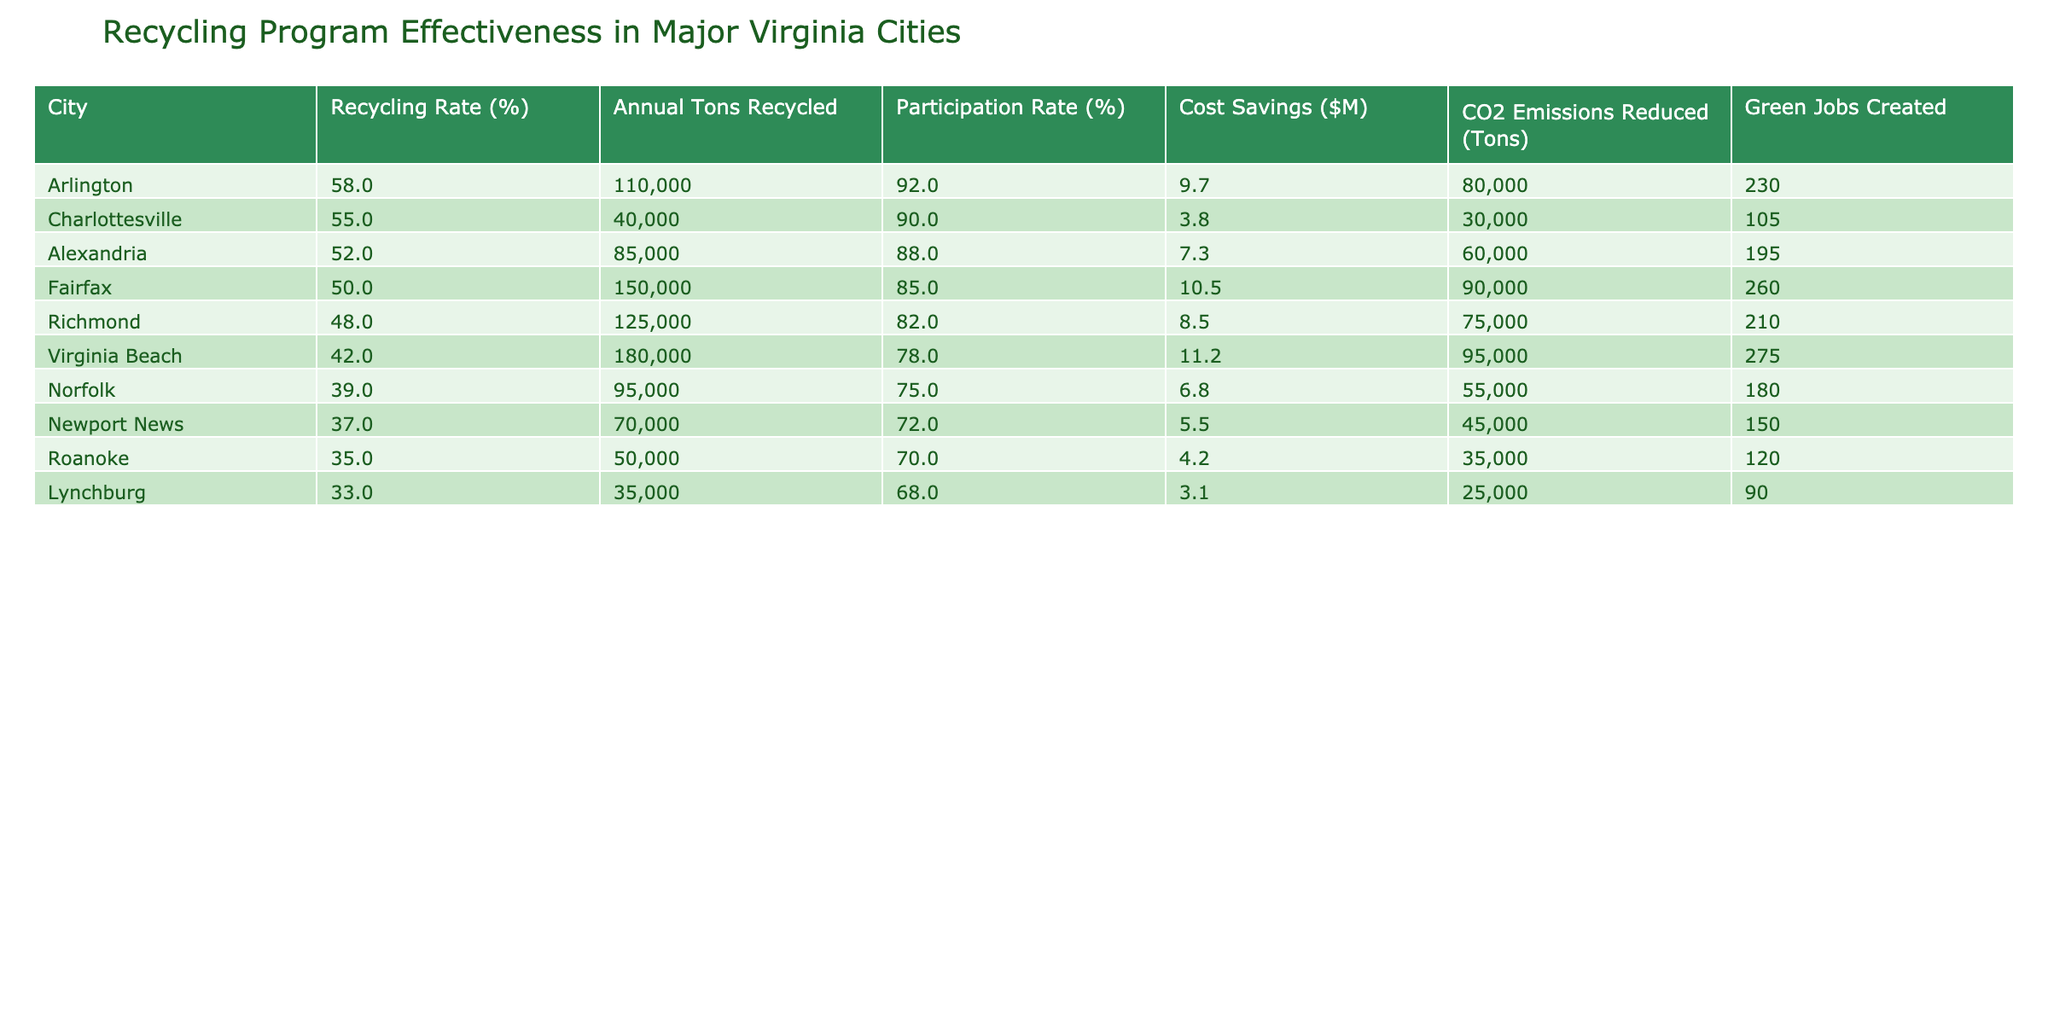What city has the highest recycling rate? By looking at the 'Recycling Rate (%)' column, Arlington has the highest value at 58%.
Answer: Arlington What is the total annual tons recycled by all cities combined? To find the total, sum the 'Annual Tons Recycled' column: 125000 + 180000 + 95000 + 85000 + 50000 + 40000 + 70000 + 35000 + 110000 + 150000 = 1,205,000 tons.
Answer: 1,205,000 Is the participation rate in Norfolk higher than that in Roanoke? The participation rate for Norfolk is 75%, and for Roanoke it is 70%. Since 75% is greater than 70%, the answer is yes.
Answer: Yes Which city has the lowest cost savings from recycling? Checking the 'Cost Savings ($M)' column, Lynchburg shows the lowest value of 3.1 million dollars.
Answer: Lynchburg What is the average recycling rate among the listed cities? The recycling rates are 48, 42, 39, 52, 35, 55, 37, 33, 58, and 50. The sum is  48 + 42 + 39 + 52 + 35 + 55 + 37 + 33 + 58 + 50 =  449. There are 10 cities, so the average is 449 / 10 = 44.9%.
Answer: 44.9 Does Virginia Beach recycle more tons annually than both Norfolk and Roanoke combined? Virginia Beach recycles 180,000 tons, while Norfolk recycles 95,000 tons and Roanoke recycles 50,000 tons combined: 95,000 + 50,000 = 145,000 tons. Since 180,000 is greater than 145,000, the answer is yes.
Answer: Yes What is the difference in CO2 emissions reduced between the highest and lowest performing cities? The highest is Arlington (80,000 tons) and the lowest is Lynchburg (25,000 tons). The difference is 80,000 - 25,000 = 55,000 tons.
Answer: 55,000 Which city created the most green jobs according to the table? The 'Green Jobs Created' column shows that Virginia Beach has the highest figure at 275 jobs created.
Answer: Virginia Beach Are there more green jobs created in Alexandria than in Fairfax? Alexandria created 195 green jobs, while Fairfax created 260. Since 195 is less than 260, the answer is no.
Answer: No 